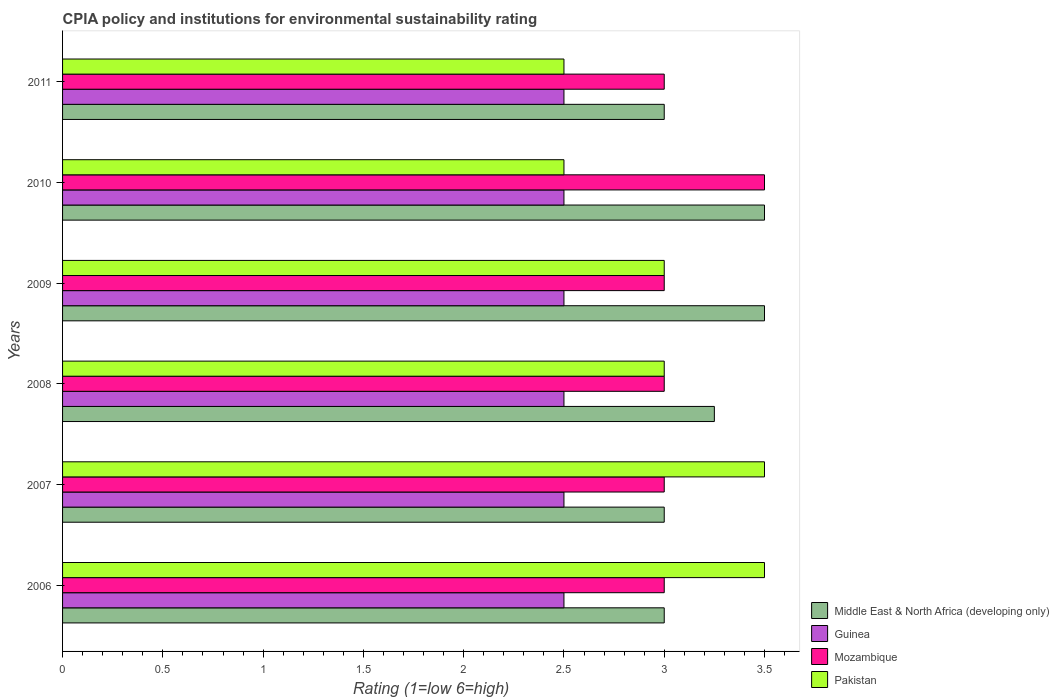How many groups of bars are there?
Make the answer very short. 6. Across all years, what is the maximum CPIA rating in Pakistan?
Your response must be concise. 3.5. Across all years, what is the minimum CPIA rating in Pakistan?
Keep it short and to the point. 2.5. In which year was the CPIA rating in Mozambique minimum?
Provide a short and direct response. 2006. What is the difference between the CPIA rating in Pakistan in 2010 and that in 2011?
Your response must be concise. 0. What is the difference between the CPIA rating in Pakistan in 2008 and the CPIA rating in Middle East & North Africa (developing only) in 2007?
Make the answer very short. 0. In the year 2009, what is the difference between the CPIA rating in Middle East & North Africa (developing only) and CPIA rating in Mozambique?
Your answer should be compact. 0.5. Is the CPIA rating in Middle East & North Africa (developing only) in 2008 less than that in 2010?
Make the answer very short. Yes. Is the difference between the CPIA rating in Middle East & North Africa (developing only) in 2006 and 2010 greater than the difference between the CPIA rating in Mozambique in 2006 and 2010?
Ensure brevity in your answer.  No. What is the difference between the highest and the lowest CPIA rating in Pakistan?
Keep it short and to the point. 1. Is the sum of the CPIA rating in Guinea in 2007 and 2010 greater than the maximum CPIA rating in Mozambique across all years?
Offer a terse response. Yes. What does the 4th bar from the top in 2011 represents?
Offer a very short reply. Middle East & North Africa (developing only). What does the 2nd bar from the bottom in 2008 represents?
Your answer should be compact. Guinea. Is it the case that in every year, the sum of the CPIA rating in Middle East & North Africa (developing only) and CPIA rating in Mozambique is greater than the CPIA rating in Guinea?
Offer a very short reply. Yes. What is the difference between two consecutive major ticks on the X-axis?
Provide a short and direct response. 0.5. Does the graph contain any zero values?
Ensure brevity in your answer.  No. Does the graph contain grids?
Provide a succinct answer. No. Where does the legend appear in the graph?
Your answer should be very brief. Bottom right. What is the title of the graph?
Offer a terse response. CPIA policy and institutions for environmental sustainability rating. Does "Kyrgyz Republic" appear as one of the legend labels in the graph?
Your response must be concise. No. What is the label or title of the X-axis?
Give a very brief answer. Rating (1=low 6=high). What is the Rating (1=low 6=high) of Middle East & North Africa (developing only) in 2006?
Keep it short and to the point. 3. What is the Rating (1=low 6=high) in Mozambique in 2006?
Your response must be concise. 3. What is the Rating (1=low 6=high) in Pakistan in 2007?
Your answer should be very brief. 3.5. What is the Rating (1=low 6=high) in Mozambique in 2008?
Provide a succinct answer. 3. What is the Rating (1=low 6=high) of Middle East & North Africa (developing only) in 2009?
Your response must be concise. 3.5. What is the Rating (1=low 6=high) in Pakistan in 2009?
Your answer should be very brief. 3. What is the Rating (1=low 6=high) in Middle East & North Africa (developing only) in 2010?
Your answer should be very brief. 3.5. What is the Rating (1=low 6=high) in Mozambique in 2010?
Provide a short and direct response. 3.5. What is the Rating (1=low 6=high) of Pakistan in 2010?
Offer a terse response. 2.5. What is the Rating (1=low 6=high) of Middle East & North Africa (developing only) in 2011?
Your answer should be compact. 3. What is the Rating (1=low 6=high) in Guinea in 2011?
Offer a very short reply. 2.5. What is the Rating (1=low 6=high) of Mozambique in 2011?
Offer a terse response. 3. What is the Rating (1=low 6=high) in Pakistan in 2011?
Provide a succinct answer. 2.5. Across all years, what is the maximum Rating (1=low 6=high) in Mozambique?
Your answer should be very brief. 3.5. Across all years, what is the maximum Rating (1=low 6=high) of Pakistan?
Offer a very short reply. 3.5. Across all years, what is the minimum Rating (1=low 6=high) in Guinea?
Your answer should be compact. 2.5. What is the total Rating (1=low 6=high) of Middle East & North Africa (developing only) in the graph?
Offer a very short reply. 19.25. What is the total Rating (1=low 6=high) of Guinea in the graph?
Provide a succinct answer. 15. What is the total Rating (1=low 6=high) of Mozambique in the graph?
Your answer should be very brief. 18.5. What is the total Rating (1=low 6=high) in Pakistan in the graph?
Offer a very short reply. 18. What is the difference between the Rating (1=low 6=high) in Guinea in 2006 and that in 2007?
Your answer should be very brief. 0. What is the difference between the Rating (1=low 6=high) of Mozambique in 2006 and that in 2007?
Your response must be concise. 0. What is the difference between the Rating (1=low 6=high) in Pakistan in 2006 and that in 2007?
Your answer should be very brief. 0. What is the difference between the Rating (1=low 6=high) of Guinea in 2006 and that in 2008?
Offer a terse response. 0. What is the difference between the Rating (1=low 6=high) of Guinea in 2006 and that in 2009?
Give a very brief answer. 0. What is the difference between the Rating (1=low 6=high) of Guinea in 2006 and that in 2010?
Ensure brevity in your answer.  0. What is the difference between the Rating (1=low 6=high) in Mozambique in 2006 and that in 2010?
Offer a very short reply. -0.5. What is the difference between the Rating (1=low 6=high) in Pakistan in 2006 and that in 2011?
Provide a succinct answer. 1. What is the difference between the Rating (1=low 6=high) of Middle East & North Africa (developing only) in 2007 and that in 2008?
Make the answer very short. -0.25. What is the difference between the Rating (1=low 6=high) of Guinea in 2007 and that in 2008?
Your answer should be very brief. 0. What is the difference between the Rating (1=low 6=high) of Pakistan in 2007 and that in 2008?
Give a very brief answer. 0.5. What is the difference between the Rating (1=low 6=high) of Guinea in 2007 and that in 2009?
Provide a succinct answer. 0. What is the difference between the Rating (1=low 6=high) in Mozambique in 2007 and that in 2009?
Offer a terse response. 0. What is the difference between the Rating (1=low 6=high) of Pakistan in 2007 and that in 2009?
Provide a short and direct response. 0.5. What is the difference between the Rating (1=low 6=high) of Middle East & North Africa (developing only) in 2007 and that in 2010?
Make the answer very short. -0.5. What is the difference between the Rating (1=low 6=high) of Guinea in 2007 and that in 2010?
Offer a very short reply. 0. What is the difference between the Rating (1=low 6=high) in Middle East & North Africa (developing only) in 2007 and that in 2011?
Keep it short and to the point. 0. What is the difference between the Rating (1=low 6=high) of Pakistan in 2007 and that in 2011?
Provide a short and direct response. 1. What is the difference between the Rating (1=low 6=high) of Mozambique in 2008 and that in 2009?
Your answer should be compact. 0. What is the difference between the Rating (1=low 6=high) of Middle East & North Africa (developing only) in 2008 and that in 2011?
Your response must be concise. 0.25. What is the difference between the Rating (1=low 6=high) in Mozambique in 2008 and that in 2011?
Provide a short and direct response. 0. What is the difference between the Rating (1=low 6=high) of Pakistan in 2008 and that in 2011?
Offer a very short reply. 0.5. What is the difference between the Rating (1=low 6=high) of Mozambique in 2009 and that in 2010?
Provide a short and direct response. -0.5. What is the difference between the Rating (1=low 6=high) in Pakistan in 2009 and that in 2010?
Your response must be concise. 0.5. What is the difference between the Rating (1=low 6=high) in Mozambique in 2009 and that in 2011?
Provide a succinct answer. 0. What is the difference between the Rating (1=low 6=high) in Pakistan in 2009 and that in 2011?
Offer a very short reply. 0.5. What is the difference between the Rating (1=low 6=high) in Middle East & North Africa (developing only) in 2010 and that in 2011?
Offer a terse response. 0.5. What is the difference between the Rating (1=low 6=high) in Mozambique in 2010 and that in 2011?
Give a very brief answer. 0.5. What is the difference between the Rating (1=low 6=high) of Middle East & North Africa (developing only) in 2006 and the Rating (1=low 6=high) of Mozambique in 2007?
Give a very brief answer. 0. What is the difference between the Rating (1=low 6=high) of Middle East & North Africa (developing only) in 2006 and the Rating (1=low 6=high) of Pakistan in 2007?
Ensure brevity in your answer.  -0.5. What is the difference between the Rating (1=low 6=high) in Mozambique in 2006 and the Rating (1=low 6=high) in Pakistan in 2007?
Your answer should be compact. -0.5. What is the difference between the Rating (1=low 6=high) of Middle East & North Africa (developing only) in 2006 and the Rating (1=low 6=high) of Mozambique in 2008?
Offer a very short reply. 0. What is the difference between the Rating (1=low 6=high) of Middle East & North Africa (developing only) in 2006 and the Rating (1=low 6=high) of Pakistan in 2008?
Provide a short and direct response. 0. What is the difference between the Rating (1=low 6=high) in Guinea in 2006 and the Rating (1=low 6=high) in Pakistan in 2008?
Offer a very short reply. -0.5. What is the difference between the Rating (1=low 6=high) in Mozambique in 2006 and the Rating (1=low 6=high) in Pakistan in 2008?
Give a very brief answer. 0. What is the difference between the Rating (1=low 6=high) in Middle East & North Africa (developing only) in 2006 and the Rating (1=low 6=high) in Guinea in 2009?
Offer a terse response. 0.5. What is the difference between the Rating (1=low 6=high) of Middle East & North Africa (developing only) in 2006 and the Rating (1=low 6=high) of Mozambique in 2009?
Provide a succinct answer. 0. What is the difference between the Rating (1=low 6=high) of Middle East & North Africa (developing only) in 2006 and the Rating (1=low 6=high) of Guinea in 2010?
Give a very brief answer. 0.5. What is the difference between the Rating (1=low 6=high) in Middle East & North Africa (developing only) in 2006 and the Rating (1=low 6=high) in Pakistan in 2010?
Offer a very short reply. 0.5. What is the difference between the Rating (1=low 6=high) of Mozambique in 2006 and the Rating (1=low 6=high) of Pakistan in 2010?
Provide a short and direct response. 0.5. What is the difference between the Rating (1=low 6=high) of Middle East & North Africa (developing only) in 2006 and the Rating (1=low 6=high) of Guinea in 2011?
Offer a terse response. 0.5. What is the difference between the Rating (1=low 6=high) in Middle East & North Africa (developing only) in 2006 and the Rating (1=low 6=high) in Pakistan in 2011?
Ensure brevity in your answer.  0.5. What is the difference between the Rating (1=low 6=high) of Guinea in 2006 and the Rating (1=low 6=high) of Pakistan in 2011?
Give a very brief answer. 0. What is the difference between the Rating (1=low 6=high) of Guinea in 2007 and the Rating (1=low 6=high) of Mozambique in 2008?
Keep it short and to the point. -0.5. What is the difference between the Rating (1=low 6=high) in Middle East & North Africa (developing only) in 2007 and the Rating (1=low 6=high) in Guinea in 2009?
Offer a very short reply. 0.5. What is the difference between the Rating (1=low 6=high) in Middle East & North Africa (developing only) in 2007 and the Rating (1=low 6=high) in Pakistan in 2009?
Offer a terse response. 0. What is the difference between the Rating (1=low 6=high) of Guinea in 2007 and the Rating (1=low 6=high) of Mozambique in 2009?
Your answer should be very brief. -0.5. What is the difference between the Rating (1=low 6=high) in Mozambique in 2007 and the Rating (1=low 6=high) in Pakistan in 2009?
Keep it short and to the point. 0. What is the difference between the Rating (1=low 6=high) of Guinea in 2007 and the Rating (1=low 6=high) of Mozambique in 2010?
Give a very brief answer. -1. What is the difference between the Rating (1=low 6=high) in Middle East & North Africa (developing only) in 2007 and the Rating (1=low 6=high) in Guinea in 2011?
Provide a short and direct response. 0.5. What is the difference between the Rating (1=low 6=high) of Middle East & North Africa (developing only) in 2007 and the Rating (1=low 6=high) of Mozambique in 2011?
Make the answer very short. 0. What is the difference between the Rating (1=low 6=high) in Guinea in 2007 and the Rating (1=low 6=high) in Mozambique in 2011?
Your answer should be compact. -0.5. What is the difference between the Rating (1=low 6=high) of Mozambique in 2007 and the Rating (1=low 6=high) of Pakistan in 2011?
Your answer should be compact. 0.5. What is the difference between the Rating (1=low 6=high) in Middle East & North Africa (developing only) in 2008 and the Rating (1=low 6=high) in Guinea in 2009?
Keep it short and to the point. 0.75. What is the difference between the Rating (1=low 6=high) in Middle East & North Africa (developing only) in 2008 and the Rating (1=low 6=high) in Mozambique in 2009?
Make the answer very short. 0.25. What is the difference between the Rating (1=low 6=high) of Middle East & North Africa (developing only) in 2008 and the Rating (1=low 6=high) of Pakistan in 2009?
Offer a very short reply. 0.25. What is the difference between the Rating (1=low 6=high) in Guinea in 2008 and the Rating (1=low 6=high) in Mozambique in 2009?
Ensure brevity in your answer.  -0.5. What is the difference between the Rating (1=low 6=high) in Guinea in 2008 and the Rating (1=low 6=high) in Pakistan in 2009?
Your response must be concise. -0.5. What is the difference between the Rating (1=low 6=high) in Guinea in 2008 and the Rating (1=low 6=high) in Pakistan in 2010?
Your response must be concise. 0. What is the difference between the Rating (1=low 6=high) of Mozambique in 2008 and the Rating (1=low 6=high) of Pakistan in 2010?
Your answer should be very brief. 0.5. What is the difference between the Rating (1=low 6=high) of Middle East & North Africa (developing only) in 2008 and the Rating (1=low 6=high) of Guinea in 2011?
Give a very brief answer. 0.75. What is the difference between the Rating (1=low 6=high) of Middle East & North Africa (developing only) in 2008 and the Rating (1=low 6=high) of Mozambique in 2011?
Ensure brevity in your answer.  0.25. What is the difference between the Rating (1=low 6=high) of Guinea in 2008 and the Rating (1=low 6=high) of Mozambique in 2011?
Offer a terse response. -0.5. What is the difference between the Rating (1=low 6=high) of Mozambique in 2008 and the Rating (1=low 6=high) of Pakistan in 2011?
Offer a terse response. 0.5. What is the difference between the Rating (1=low 6=high) of Middle East & North Africa (developing only) in 2009 and the Rating (1=low 6=high) of Guinea in 2010?
Make the answer very short. 1. What is the difference between the Rating (1=low 6=high) of Middle East & North Africa (developing only) in 2009 and the Rating (1=low 6=high) of Mozambique in 2010?
Provide a succinct answer. 0. What is the difference between the Rating (1=low 6=high) of Guinea in 2009 and the Rating (1=low 6=high) of Mozambique in 2010?
Your response must be concise. -1. What is the difference between the Rating (1=low 6=high) in Middle East & North Africa (developing only) in 2009 and the Rating (1=low 6=high) in Pakistan in 2011?
Make the answer very short. 1. What is the difference between the Rating (1=low 6=high) of Guinea in 2009 and the Rating (1=low 6=high) of Mozambique in 2011?
Provide a succinct answer. -0.5. What is the difference between the Rating (1=low 6=high) in Mozambique in 2009 and the Rating (1=low 6=high) in Pakistan in 2011?
Offer a terse response. 0.5. What is the difference between the Rating (1=low 6=high) in Middle East & North Africa (developing only) in 2010 and the Rating (1=low 6=high) in Guinea in 2011?
Ensure brevity in your answer.  1. What is the difference between the Rating (1=low 6=high) in Middle East & North Africa (developing only) in 2010 and the Rating (1=low 6=high) in Pakistan in 2011?
Your answer should be very brief. 1. What is the difference between the Rating (1=low 6=high) in Guinea in 2010 and the Rating (1=low 6=high) in Mozambique in 2011?
Ensure brevity in your answer.  -0.5. What is the difference between the Rating (1=low 6=high) of Guinea in 2010 and the Rating (1=low 6=high) of Pakistan in 2011?
Your response must be concise. 0. What is the average Rating (1=low 6=high) in Middle East & North Africa (developing only) per year?
Your answer should be very brief. 3.21. What is the average Rating (1=low 6=high) of Mozambique per year?
Provide a short and direct response. 3.08. What is the average Rating (1=low 6=high) in Pakistan per year?
Your answer should be compact. 3. In the year 2006, what is the difference between the Rating (1=low 6=high) of Middle East & North Africa (developing only) and Rating (1=low 6=high) of Guinea?
Your answer should be very brief. 0.5. In the year 2006, what is the difference between the Rating (1=low 6=high) of Middle East & North Africa (developing only) and Rating (1=low 6=high) of Mozambique?
Keep it short and to the point. 0. In the year 2006, what is the difference between the Rating (1=low 6=high) in Guinea and Rating (1=low 6=high) in Pakistan?
Provide a succinct answer. -1. In the year 2006, what is the difference between the Rating (1=low 6=high) in Mozambique and Rating (1=low 6=high) in Pakistan?
Provide a succinct answer. -0.5. In the year 2007, what is the difference between the Rating (1=low 6=high) of Middle East & North Africa (developing only) and Rating (1=low 6=high) of Guinea?
Make the answer very short. 0.5. In the year 2007, what is the difference between the Rating (1=low 6=high) in Middle East & North Africa (developing only) and Rating (1=low 6=high) in Mozambique?
Give a very brief answer. 0. In the year 2007, what is the difference between the Rating (1=low 6=high) of Middle East & North Africa (developing only) and Rating (1=low 6=high) of Pakistan?
Make the answer very short. -0.5. In the year 2007, what is the difference between the Rating (1=low 6=high) of Mozambique and Rating (1=low 6=high) of Pakistan?
Ensure brevity in your answer.  -0.5. In the year 2008, what is the difference between the Rating (1=low 6=high) of Middle East & North Africa (developing only) and Rating (1=low 6=high) of Pakistan?
Your response must be concise. 0.25. In the year 2009, what is the difference between the Rating (1=low 6=high) in Middle East & North Africa (developing only) and Rating (1=low 6=high) in Guinea?
Provide a short and direct response. 1. In the year 2009, what is the difference between the Rating (1=low 6=high) of Middle East & North Africa (developing only) and Rating (1=low 6=high) of Mozambique?
Give a very brief answer. 0.5. In the year 2009, what is the difference between the Rating (1=low 6=high) in Guinea and Rating (1=low 6=high) in Pakistan?
Offer a terse response. -0.5. In the year 2009, what is the difference between the Rating (1=low 6=high) in Mozambique and Rating (1=low 6=high) in Pakistan?
Keep it short and to the point. 0. In the year 2010, what is the difference between the Rating (1=low 6=high) of Middle East & North Africa (developing only) and Rating (1=low 6=high) of Pakistan?
Your answer should be compact. 1. In the year 2010, what is the difference between the Rating (1=low 6=high) in Guinea and Rating (1=low 6=high) in Mozambique?
Your answer should be very brief. -1. In the year 2010, what is the difference between the Rating (1=low 6=high) of Guinea and Rating (1=low 6=high) of Pakistan?
Offer a very short reply. 0. In the year 2011, what is the difference between the Rating (1=low 6=high) of Middle East & North Africa (developing only) and Rating (1=low 6=high) of Guinea?
Your answer should be compact. 0.5. In the year 2011, what is the difference between the Rating (1=low 6=high) in Guinea and Rating (1=low 6=high) in Pakistan?
Provide a short and direct response. 0. What is the ratio of the Rating (1=low 6=high) of Guinea in 2006 to that in 2007?
Make the answer very short. 1. What is the ratio of the Rating (1=low 6=high) in Pakistan in 2006 to that in 2007?
Keep it short and to the point. 1. What is the ratio of the Rating (1=low 6=high) of Middle East & North Africa (developing only) in 2006 to that in 2008?
Your answer should be very brief. 0.92. What is the ratio of the Rating (1=low 6=high) of Guinea in 2006 to that in 2008?
Offer a terse response. 1. What is the ratio of the Rating (1=low 6=high) of Mozambique in 2006 to that in 2008?
Ensure brevity in your answer.  1. What is the ratio of the Rating (1=low 6=high) in Guinea in 2006 to that in 2009?
Your answer should be compact. 1. What is the ratio of the Rating (1=low 6=high) of Pakistan in 2006 to that in 2009?
Your response must be concise. 1.17. What is the ratio of the Rating (1=low 6=high) of Middle East & North Africa (developing only) in 2006 to that in 2010?
Offer a very short reply. 0.86. What is the ratio of the Rating (1=low 6=high) in Mozambique in 2006 to that in 2011?
Provide a succinct answer. 1. What is the ratio of the Rating (1=low 6=high) of Middle East & North Africa (developing only) in 2007 to that in 2008?
Your answer should be very brief. 0.92. What is the ratio of the Rating (1=low 6=high) in Mozambique in 2007 to that in 2008?
Make the answer very short. 1. What is the ratio of the Rating (1=low 6=high) of Pakistan in 2007 to that in 2008?
Offer a very short reply. 1.17. What is the ratio of the Rating (1=low 6=high) in Middle East & North Africa (developing only) in 2007 to that in 2009?
Make the answer very short. 0.86. What is the ratio of the Rating (1=low 6=high) of Pakistan in 2007 to that in 2009?
Your answer should be very brief. 1.17. What is the ratio of the Rating (1=low 6=high) in Middle East & North Africa (developing only) in 2007 to that in 2010?
Provide a succinct answer. 0.86. What is the ratio of the Rating (1=low 6=high) of Guinea in 2007 to that in 2010?
Ensure brevity in your answer.  1. What is the ratio of the Rating (1=low 6=high) of Pakistan in 2007 to that in 2010?
Give a very brief answer. 1.4. What is the ratio of the Rating (1=low 6=high) of Middle East & North Africa (developing only) in 2007 to that in 2011?
Provide a succinct answer. 1. What is the ratio of the Rating (1=low 6=high) in Guinea in 2007 to that in 2011?
Give a very brief answer. 1. What is the ratio of the Rating (1=low 6=high) of Middle East & North Africa (developing only) in 2008 to that in 2009?
Make the answer very short. 0.93. What is the ratio of the Rating (1=low 6=high) of Guinea in 2008 to that in 2009?
Your answer should be very brief. 1. What is the ratio of the Rating (1=low 6=high) of Pakistan in 2008 to that in 2009?
Ensure brevity in your answer.  1. What is the ratio of the Rating (1=low 6=high) in Guinea in 2008 to that in 2010?
Offer a very short reply. 1. What is the ratio of the Rating (1=low 6=high) of Mozambique in 2008 to that in 2010?
Offer a terse response. 0.86. What is the ratio of the Rating (1=low 6=high) of Middle East & North Africa (developing only) in 2008 to that in 2011?
Your response must be concise. 1.08. What is the ratio of the Rating (1=low 6=high) of Mozambique in 2009 to that in 2010?
Your answer should be very brief. 0.86. What is the ratio of the Rating (1=low 6=high) of Pakistan in 2009 to that in 2010?
Your answer should be very brief. 1.2. What is the ratio of the Rating (1=low 6=high) in Guinea in 2009 to that in 2011?
Give a very brief answer. 1. What is the ratio of the Rating (1=low 6=high) of Pakistan in 2009 to that in 2011?
Provide a short and direct response. 1.2. What is the ratio of the Rating (1=low 6=high) in Middle East & North Africa (developing only) in 2010 to that in 2011?
Your answer should be very brief. 1.17. What is the ratio of the Rating (1=low 6=high) in Guinea in 2010 to that in 2011?
Offer a very short reply. 1. What is the ratio of the Rating (1=low 6=high) in Mozambique in 2010 to that in 2011?
Keep it short and to the point. 1.17. What is the difference between the highest and the second highest Rating (1=low 6=high) in Middle East & North Africa (developing only)?
Give a very brief answer. 0. What is the difference between the highest and the second highest Rating (1=low 6=high) in Guinea?
Give a very brief answer. 0. What is the difference between the highest and the second highest Rating (1=low 6=high) in Mozambique?
Provide a short and direct response. 0.5. What is the difference between the highest and the lowest Rating (1=low 6=high) of Middle East & North Africa (developing only)?
Give a very brief answer. 0.5. What is the difference between the highest and the lowest Rating (1=low 6=high) in Mozambique?
Your answer should be very brief. 0.5. 